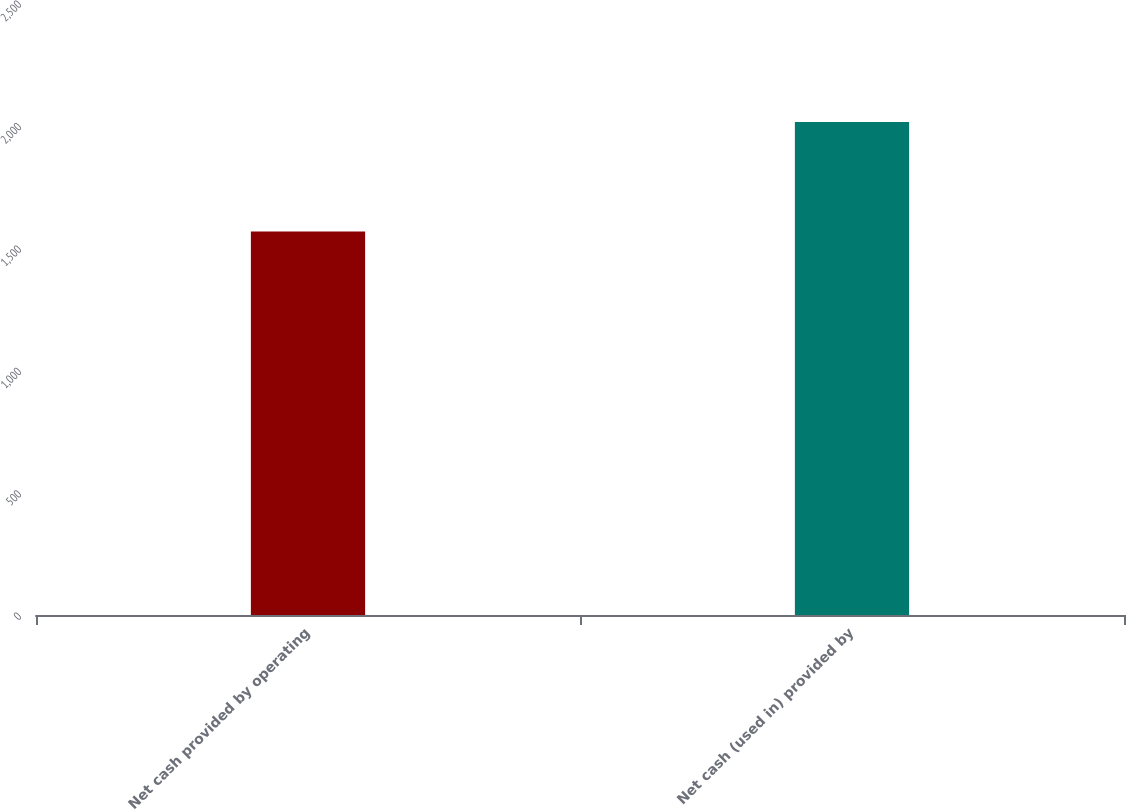Convert chart to OTSL. <chart><loc_0><loc_0><loc_500><loc_500><bar_chart><fcel>Net cash provided by operating<fcel>Net cash (used in) provided by<nl><fcel>1567<fcel>2014<nl></chart> 